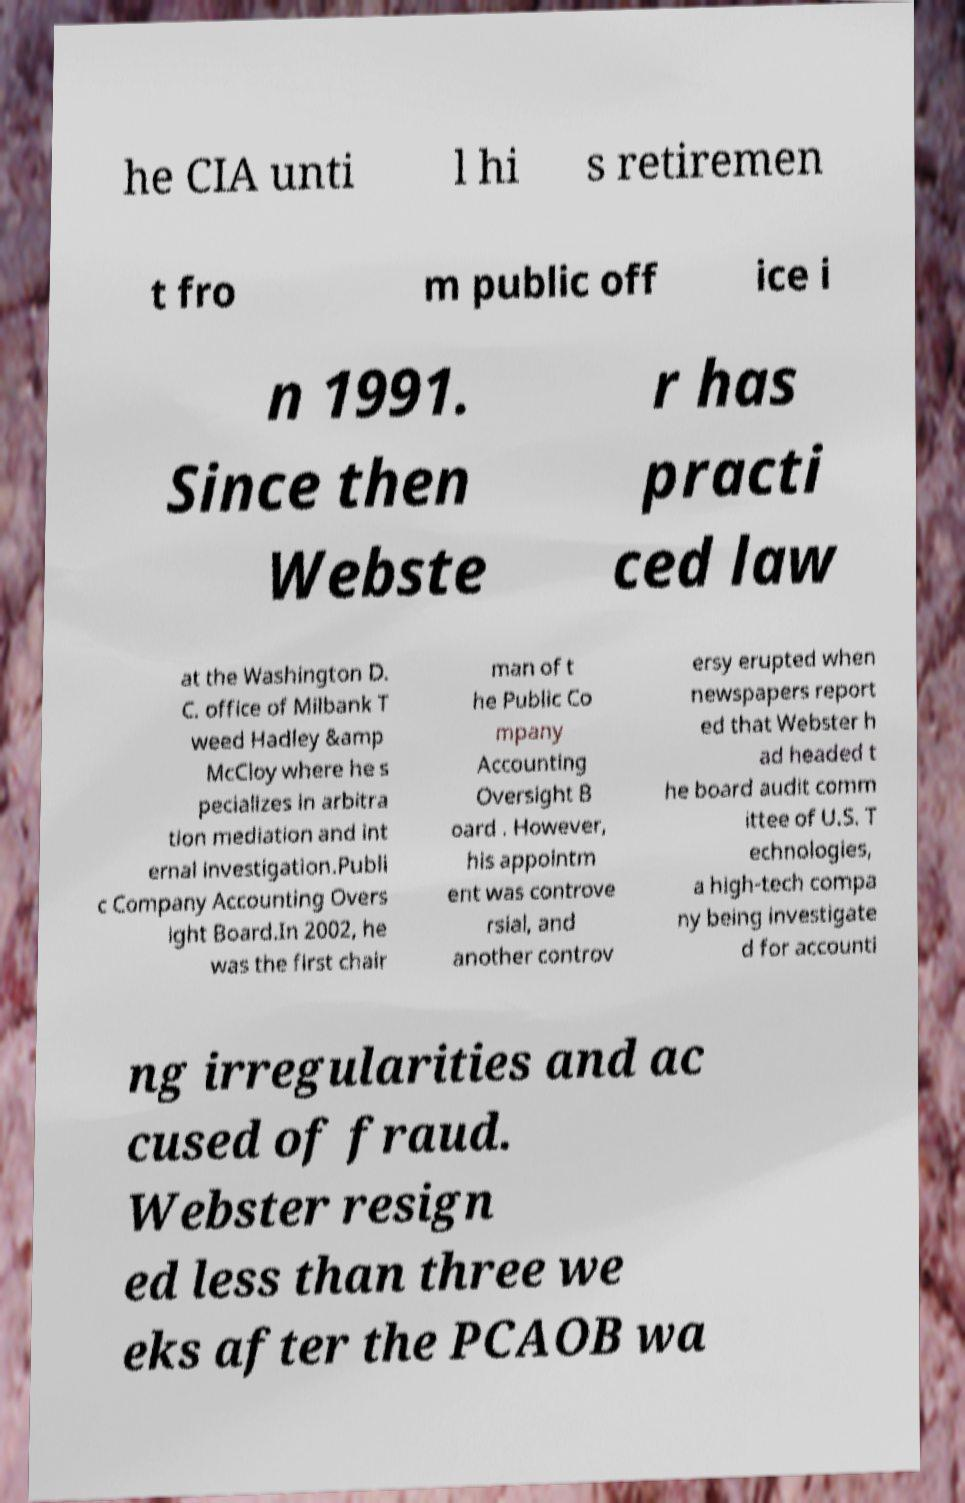Can you accurately transcribe the text from the provided image for me? he CIA unti l hi s retiremen t fro m public off ice i n 1991. Since then Webste r has practi ced law at the Washington D. C. office of Milbank T weed Hadley &amp McCloy where he s pecializes in arbitra tion mediation and int ernal investigation.Publi c Company Accounting Overs ight Board.In 2002, he was the first chair man of t he Public Co mpany Accounting Oversight B oard . However, his appointm ent was controve rsial, and another controv ersy erupted when newspapers report ed that Webster h ad headed t he board audit comm ittee of U.S. T echnologies, a high-tech compa ny being investigate d for accounti ng irregularities and ac cused of fraud. Webster resign ed less than three we eks after the PCAOB wa 